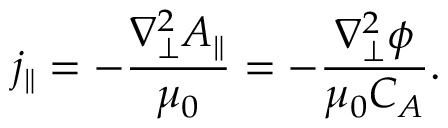<formula> <loc_0><loc_0><loc_500><loc_500>j _ { \| } = - \frac { \nabla _ { \perp } ^ { 2 } A _ { \| } } { \mu _ { 0 } } = - \frac { \nabla _ { \perp } ^ { 2 } \phi } { \mu _ { 0 } C _ { A } } .</formula> 